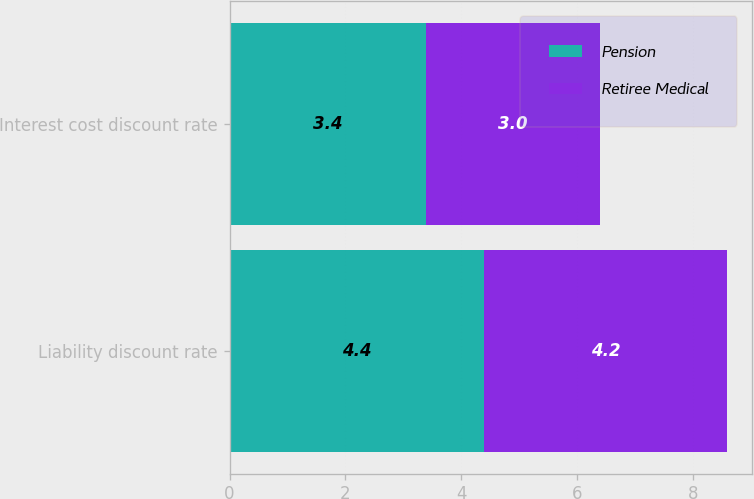<chart> <loc_0><loc_0><loc_500><loc_500><stacked_bar_chart><ecel><fcel>Liability discount rate<fcel>Interest cost discount rate<nl><fcel>Pension<fcel>4.4<fcel>3.4<nl><fcel>Retiree Medical<fcel>4.2<fcel>3<nl></chart> 